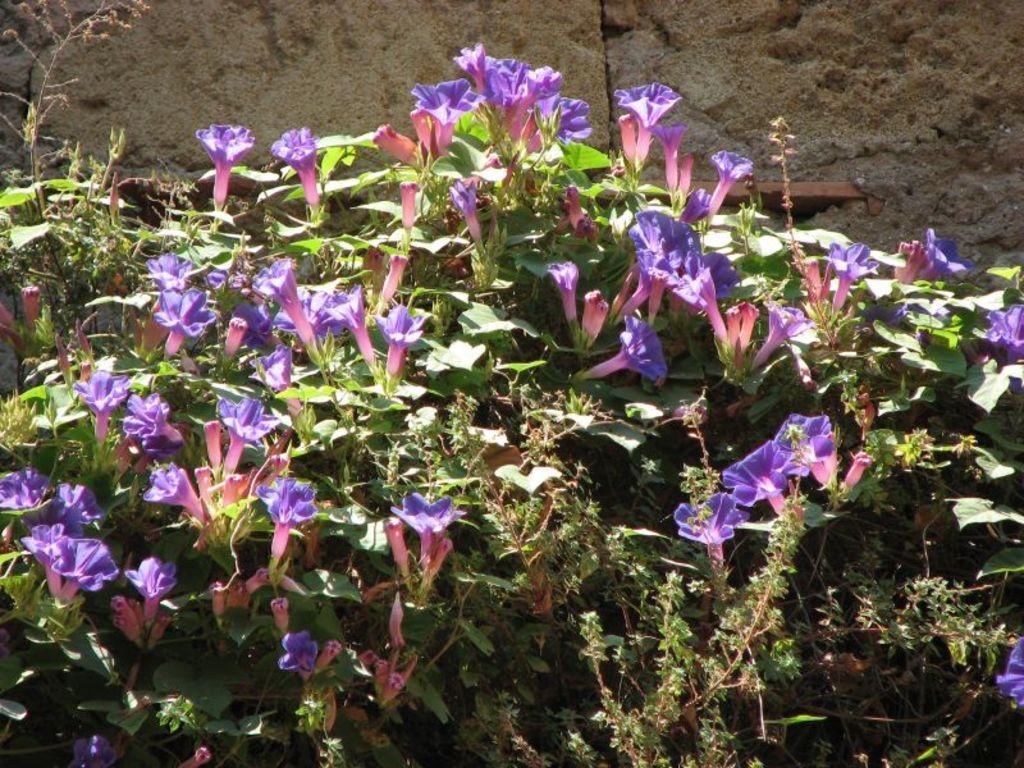Please provide a concise description of this image. In the image we can see some plants and flowers. Behind the plants there is wall. 